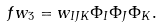<formula> <loc_0><loc_0><loc_500><loc_500>\ f w _ { 3 } = w _ { I J K } \Phi _ { I } \Phi _ { J } \Phi _ { K } .</formula> 